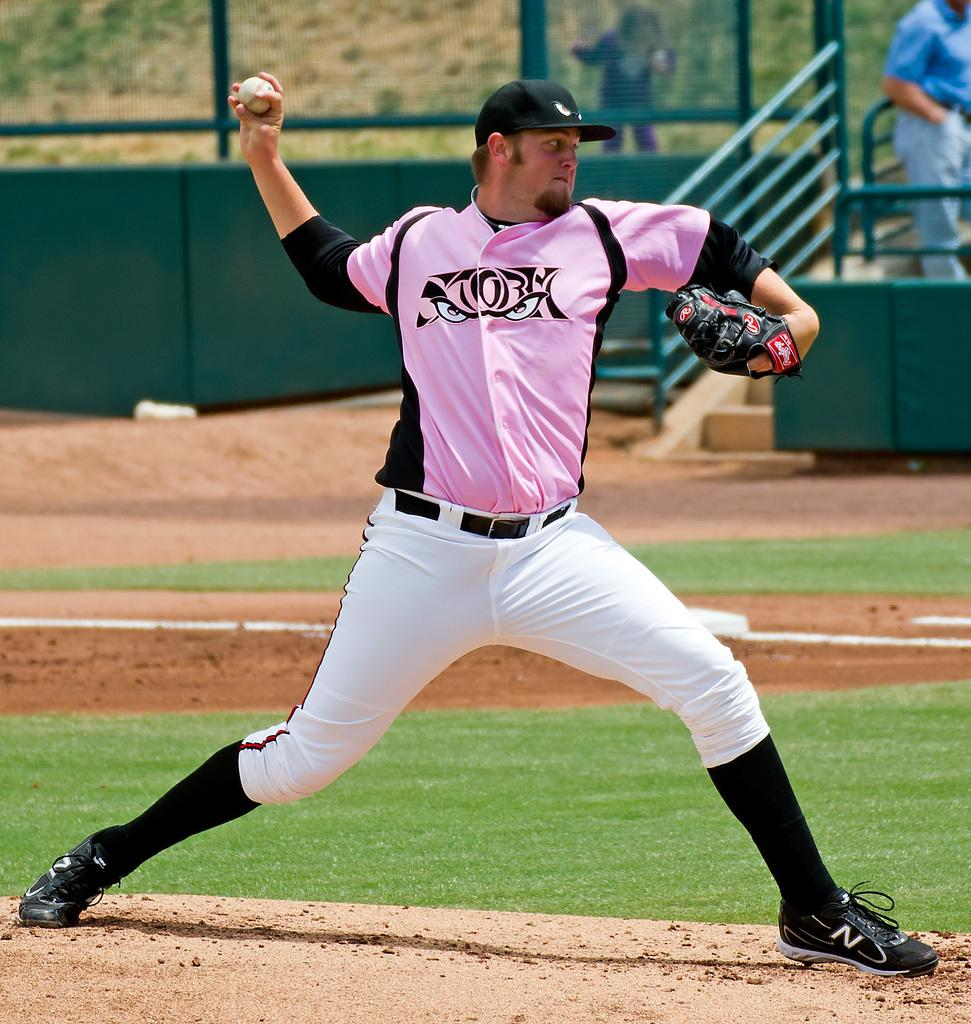<image>
Provide a brief description of the given image. a person throwing a ball with the name Storm on it 